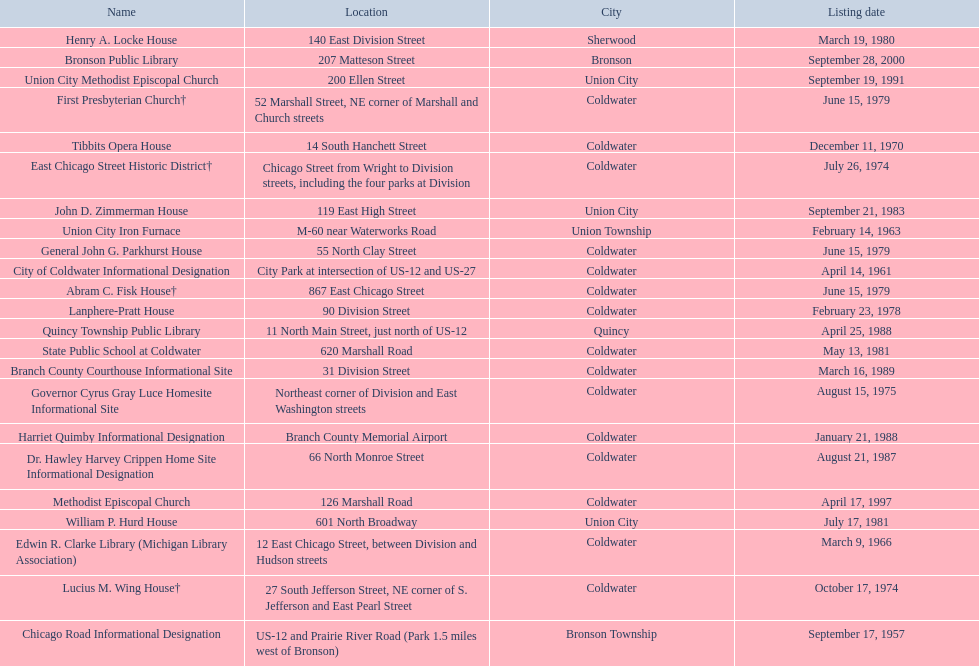How many historic sites are listed in coldwater? 15. 